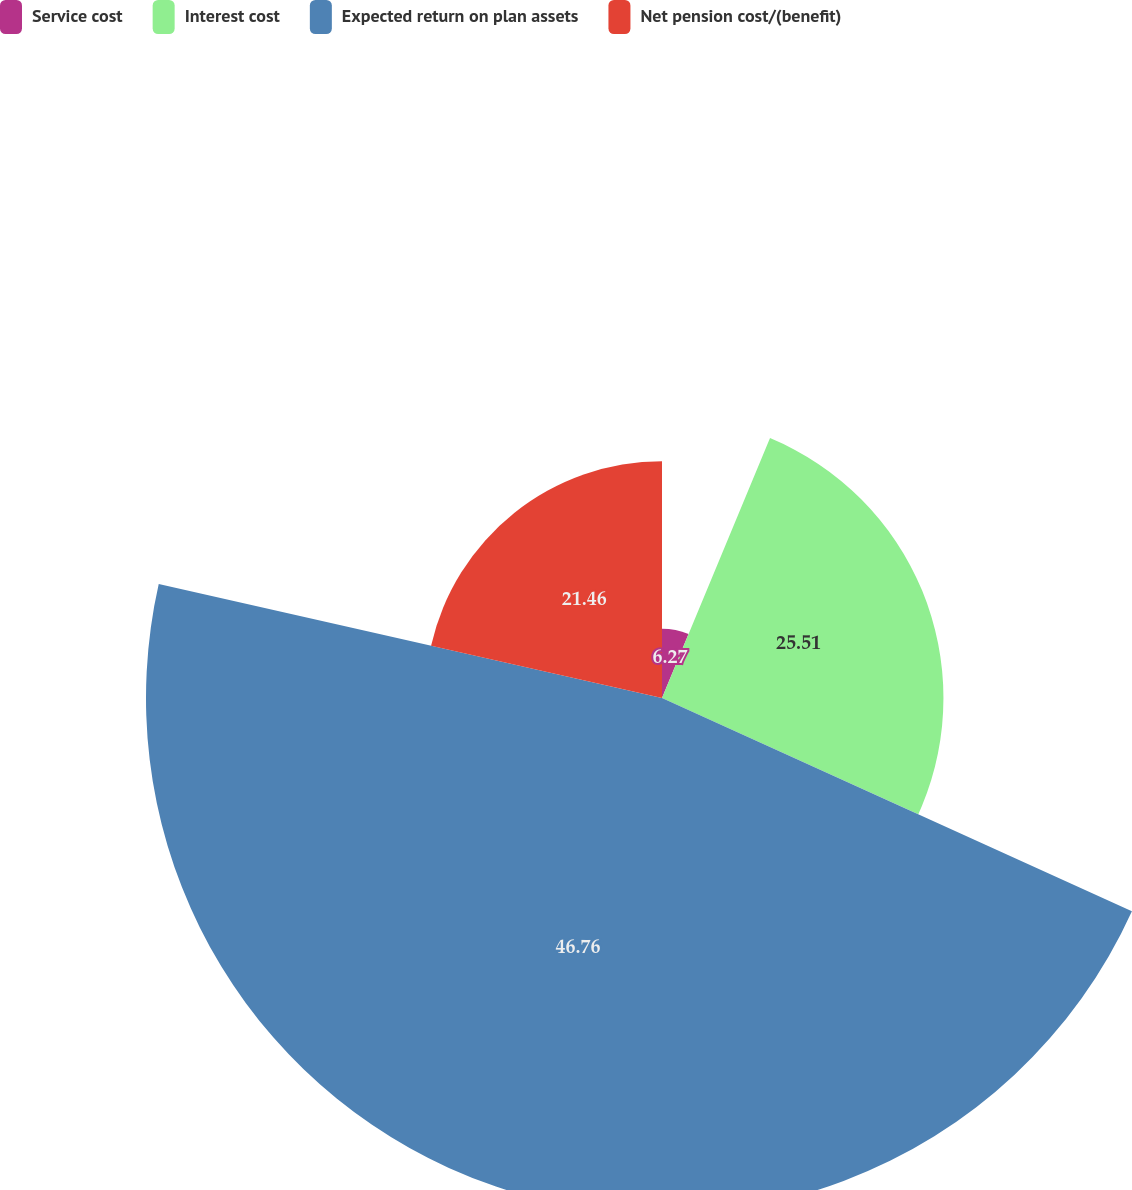Convert chart. <chart><loc_0><loc_0><loc_500><loc_500><pie_chart><fcel>Service cost<fcel>Interest cost<fcel>Expected return on plan assets<fcel>Net pension cost/(benefit)<nl><fcel>6.27%<fcel>25.51%<fcel>46.77%<fcel>21.46%<nl></chart> 